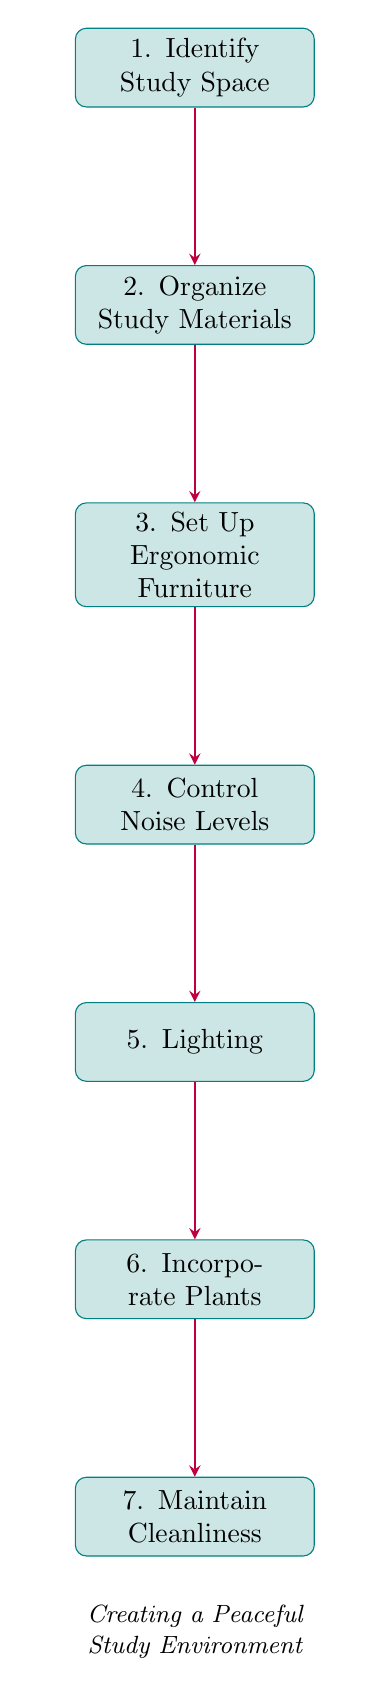What is the first step in creating a peaceful study environment? The diagram indicates that the first step is "Identify Study Space," which is the topmost node in the flow chart.
Answer: Identify Study Space How many nodes are present in the diagram? Counting all unique steps in the flow chart, there are a total of seven nodes representing various steps in creating a peaceful study environment.
Answer: Seven What is the last node in the flow? The flow ends at the node labeled "Maintain Cleanliness," which is the bottommost step when reading through the diagram.
Answer: Maintain Cleanliness Which node comes after "Control Noise Levels"? The diagram shows that directly after "Control Noise Levels" is the node "Lighting," indicating the next step in the flow.
Answer: Lighting What is the relationship between "Incorporate Plants" and "Maintain Cleanliness"? "Incorporate Plants" leads directly to "Maintain Cleanliness," creating a continuous flow where adding plants is followed by the action of keeping the study area tidy.
Answer: Incorporate Plants leads to Maintain Cleanliness What step involves reducing physical strain? The step focused on reducing physical strain is "Set Up Ergonomic Furniture," as it explicitly details the use of comfortable furniture for that purpose.
Answer: Set Up Ergonomic Furniture What type of lighting is suggested for a study environment? The node labeled "Lighting" instructs to ensure the study area is well-lit, specifically mentioning "natural or soft artificial light."
Answer: Natural or soft artificial light What is required to control noise levels? The node "Control Noise Levels" recommends using "noise-canceling headphones or play soothing background music" as methods to achieve this.
Answer: Noise-canceling headphones or soothing background music 